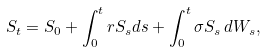Convert formula to latex. <formula><loc_0><loc_0><loc_500><loc_500>S _ { t } = S _ { 0 } + \int _ { 0 } ^ { t } r S _ { s } d s + \int _ { 0 } ^ { t } \sigma S _ { s } \, d W _ { s } ,</formula> 